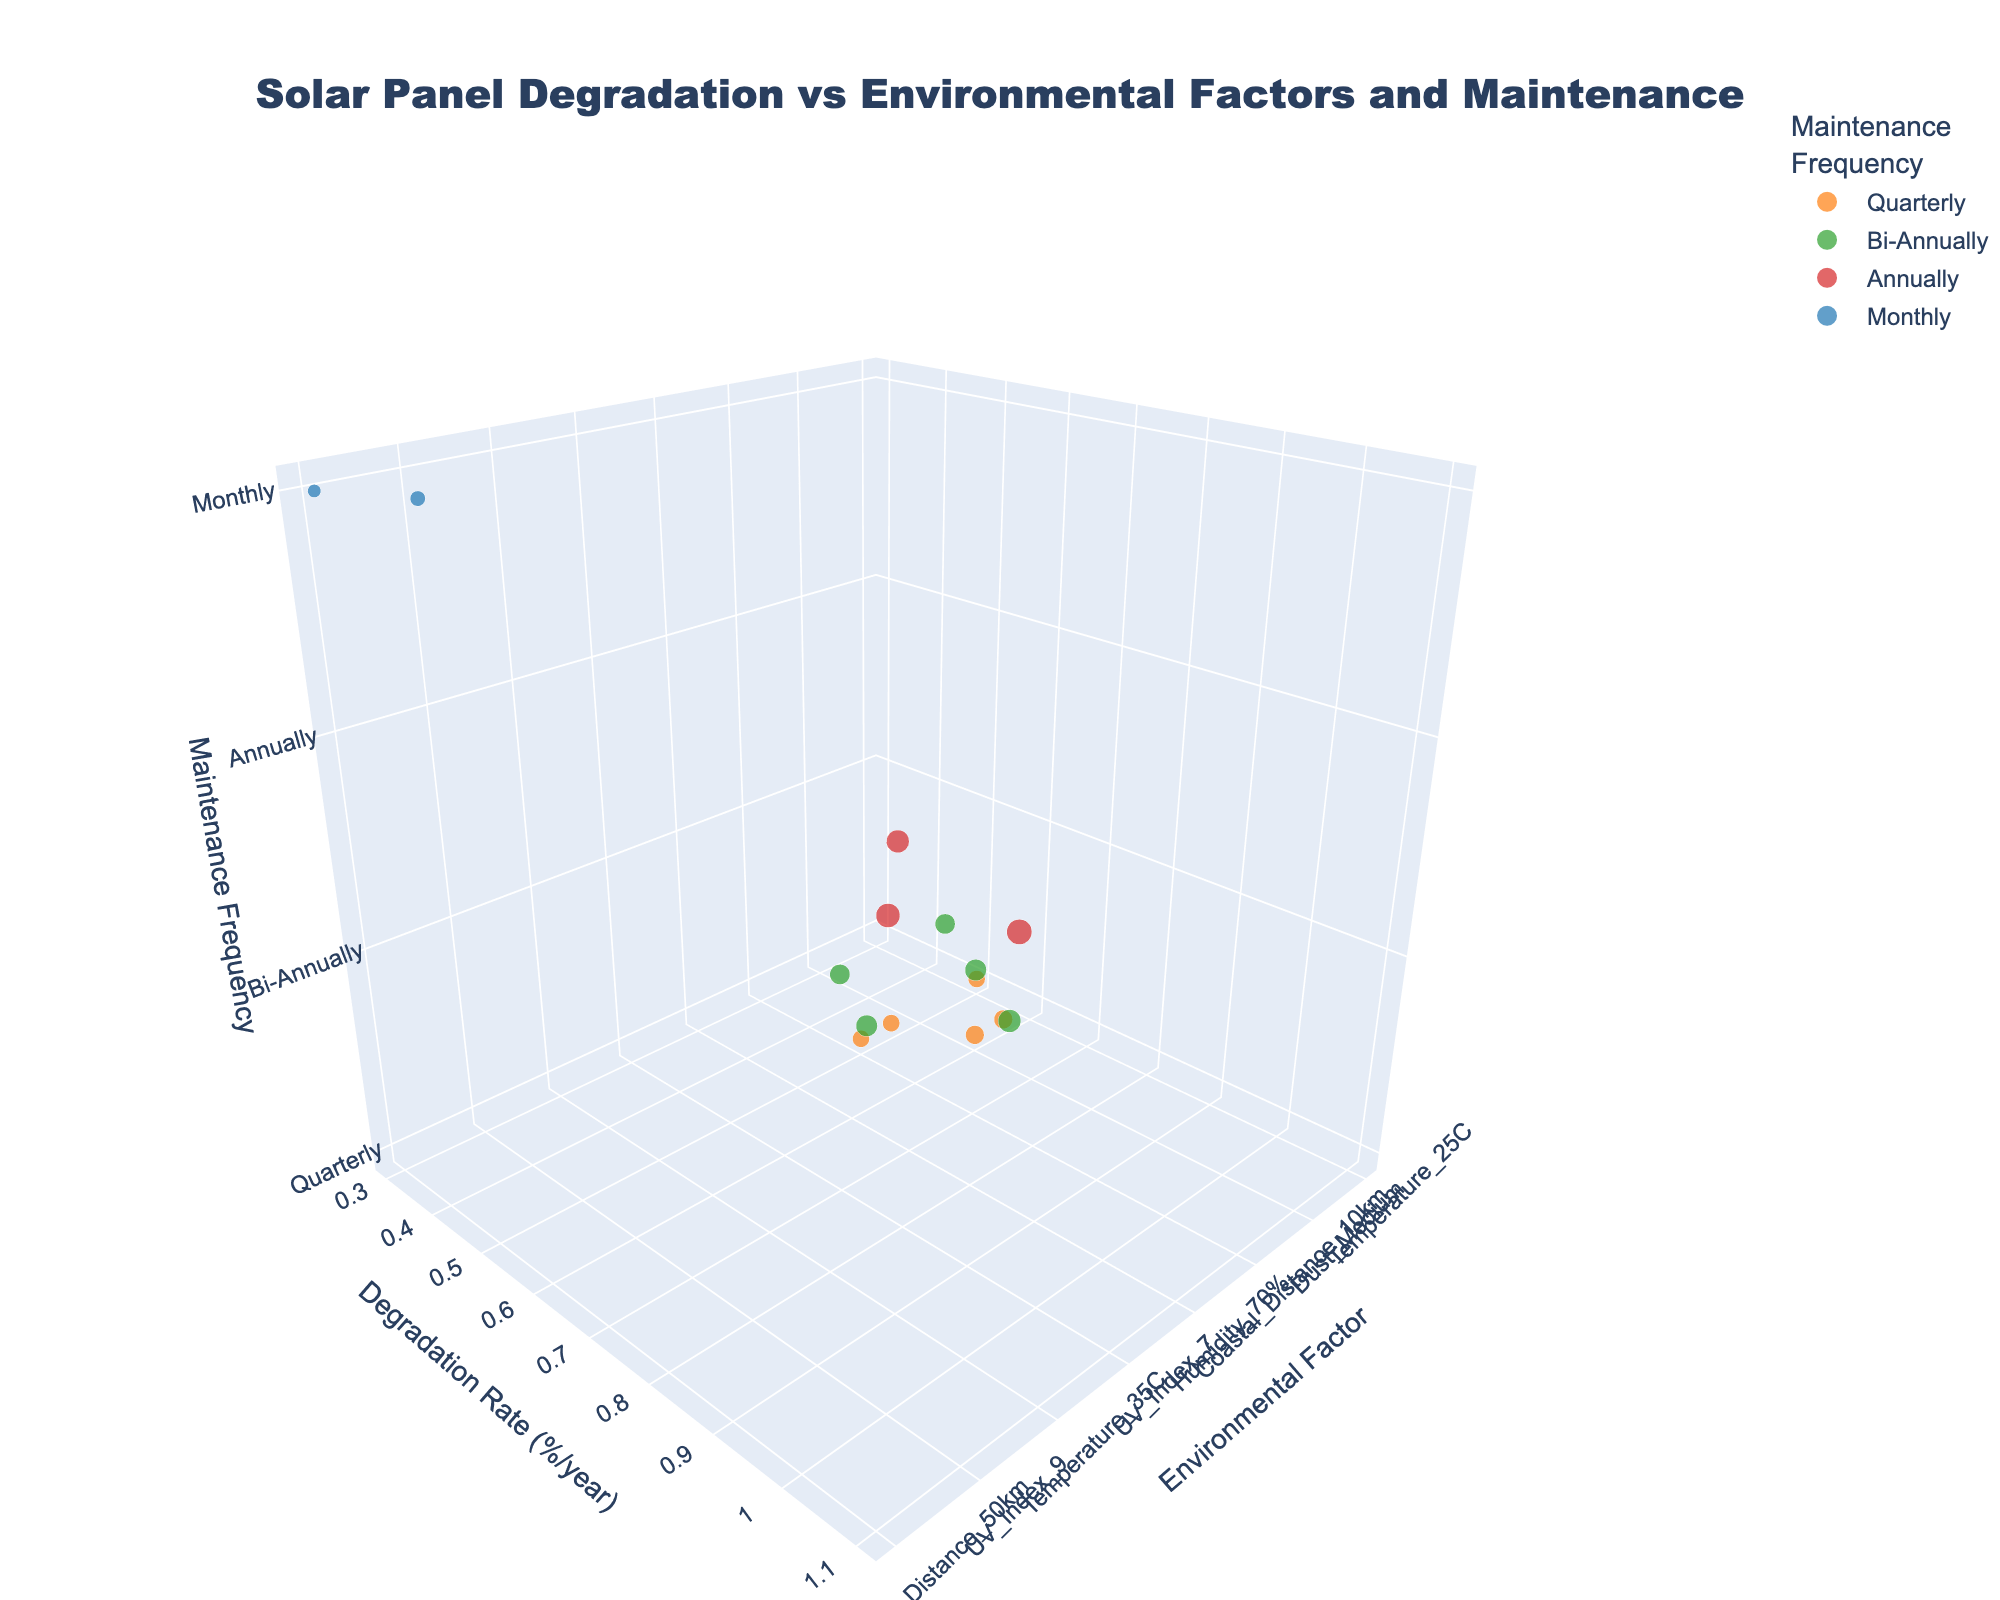What is the title of the scatter plot? The title is displayed at the top of the figure. It reads, "Solar Panel Degradation vs Environmental Factors and Maintenance."
Answer: Solar Panel Degradation vs Environmental Factors and Maintenance Which environmental factor corresponds to the highest degradation rate? Looking at the vertical axis (Degradation Rate), the highest point is at 1.1, which corresponds to "Humidity_90%" on the horizontal axis (Environmental Factor).
Answer: Humidity_90% How often are solar panels maintained in conditions represented by "Temperature_35C"? Locate the "Temperature_35C" label on the Environmental Factor axis, then look at the Maintenance Frequency associated with it, which is positioned at the "Annually" level on the Maintenance Frequency axis.
Answer: Annually What's the median degradation rate for the dust-related environmental factors? First, locate the dust-related environmental factors ("Dust_Low," "Dust_Medium," "Dust_High"). Their degradation rates are 0.4, 0.6, and 0.9 respectively. To find the median, sort these values and pick the middle one: 0.4, 0.6, 0.9. The middle value is 0.6.
Answer: 0.6 Compare the degradation rates between "Quarterly" and "Annually" maintenance frequencies. Which frequency corresponds to generally higher degradation rates? Identify data points associated with "Quarterly" (degradation rates: 0.5, 0.6, 0.5) and "Annually" (degradation rates: 0.9, 1.1, 1.0). "Annually" has higher average degradation rates than "Quarterly."
Answer: Annually Which maintenance frequency has the least degradation rate and what is the corresponding environmental factor? Identify the smallest degradation rate among all data points, which is 0.3. This corresponds to "Monthly" maintenance for the environmental factor "Coastal_Distance_50km."
Answer: Monthly, Coastal_Distance_50km Which environmental factors correspond to Bi-Annually maintenance frequency? Look at all the data points colored according to the maintenance frequency. The points colored green (Bi-Annually) correspond to the following environmental factors: "Temperature_30C," "Humidity_70%," "Dust_High," "UV_Index_7," and "Coastal_Distance_1km."
Answer: Temperature_30C, Humidity_70%, Dust_High, UV_Index_7, Coastal_Distance_1km What is the range of degradation rates for solar panels maintained "Quarterly"? Identify the data points corresponding to "Quarterly" (degradation rates: 0.5, 0.6, 0.5). The range is calculated as the difference between the highest and the lowest rates, which is 0.6 - 0.5.
Answer: 0.1 